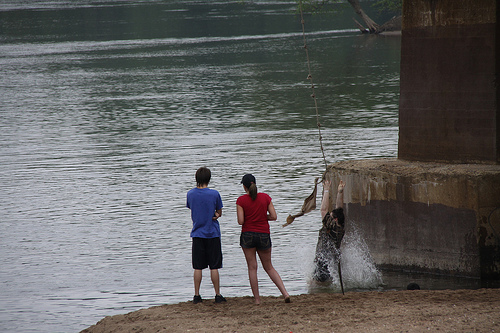<image>
Is the rope on the stone? Yes. Looking at the image, I can see the rope is positioned on top of the stone, with the stone providing support. 